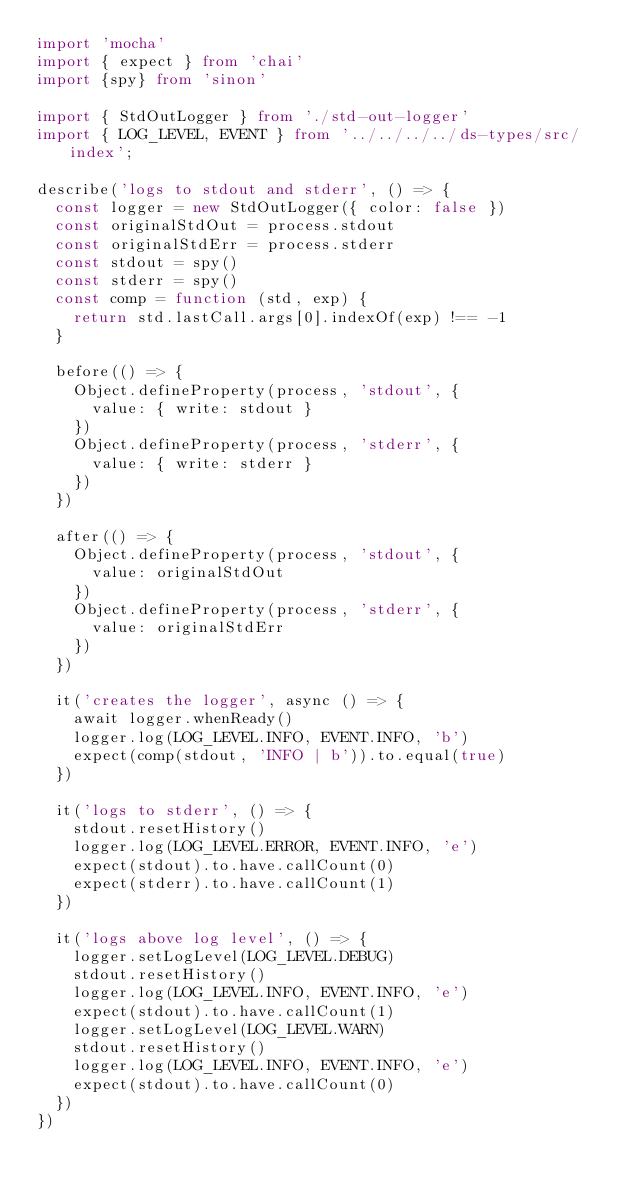<code> <loc_0><loc_0><loc_500><loc_500><_TypeScript_>import 'mocha'
import { expect } from 'chai'
import {spy} from 'sinon'

import { StdOutLogger } from './std-out-logger'
import { LOG_LEVEL, EVENT } from '../../../../ds-types/src/index';

describe('logs to stdout and stderr', () => {
  const logger = new StdOutLogger({ color: false })
  const originalStdOut = process.stdout
  const originalStdErr = process.stderr
  const stdout = spy()
  const stderr = spy()
  const comp = function (std, exp) {
    return std.lastCall.args[0].indexOf(exp) !== -1
  }

  before(() => {
    Object.defineProperty(process, 'stdout', {
      value: { write: stdout }
    })
    Object.defineProperty(process, 'stderr', {
      value: { write: stderr }
    })
  })

  after(() => {
    Object.defineProperty(process, 'stdout', {
      value: originalStdOut
    })
    Object.defineProperty(process, 'stderr', {
      value: originalStdErr
    })
  })

  it('creates the logger', async () => {
    await logger.whenReady()
    logger.log(LOG_LEVEL.INFO, EVENT.INFO, 'b')
    expect(comp(stdout, 'INFO | b')).to.equal(true)
  })

  it('logs to stderr', () => {
    stdout.resetHistory()
    logger.log(LOG_LEVEL.ERROR, EVENT.INFO, 'e')
    expect(stdout).to.have.callCount(0)
    expect(stderr).to.have.callCount(1)
  })

  it('logs above log level', () => {
    logger.setLogLevel(LOG_LEVEL.DEBUG)
    stdout.resetHistory()
    logger.log(LOG_LEVEL.INFO, EVENT.INFO, 'e')
    expect(stdout).to.have.callCount(1)
    logger.setLogLevel(LOG_LEVEL.WARN)
    stdout.resetHistory()
    logger.log(LOG_LEVEL.INFO, EVENT.INFO, 'e')
    expect(stdout).to.have.callCount(0)
  })
})
</code> 